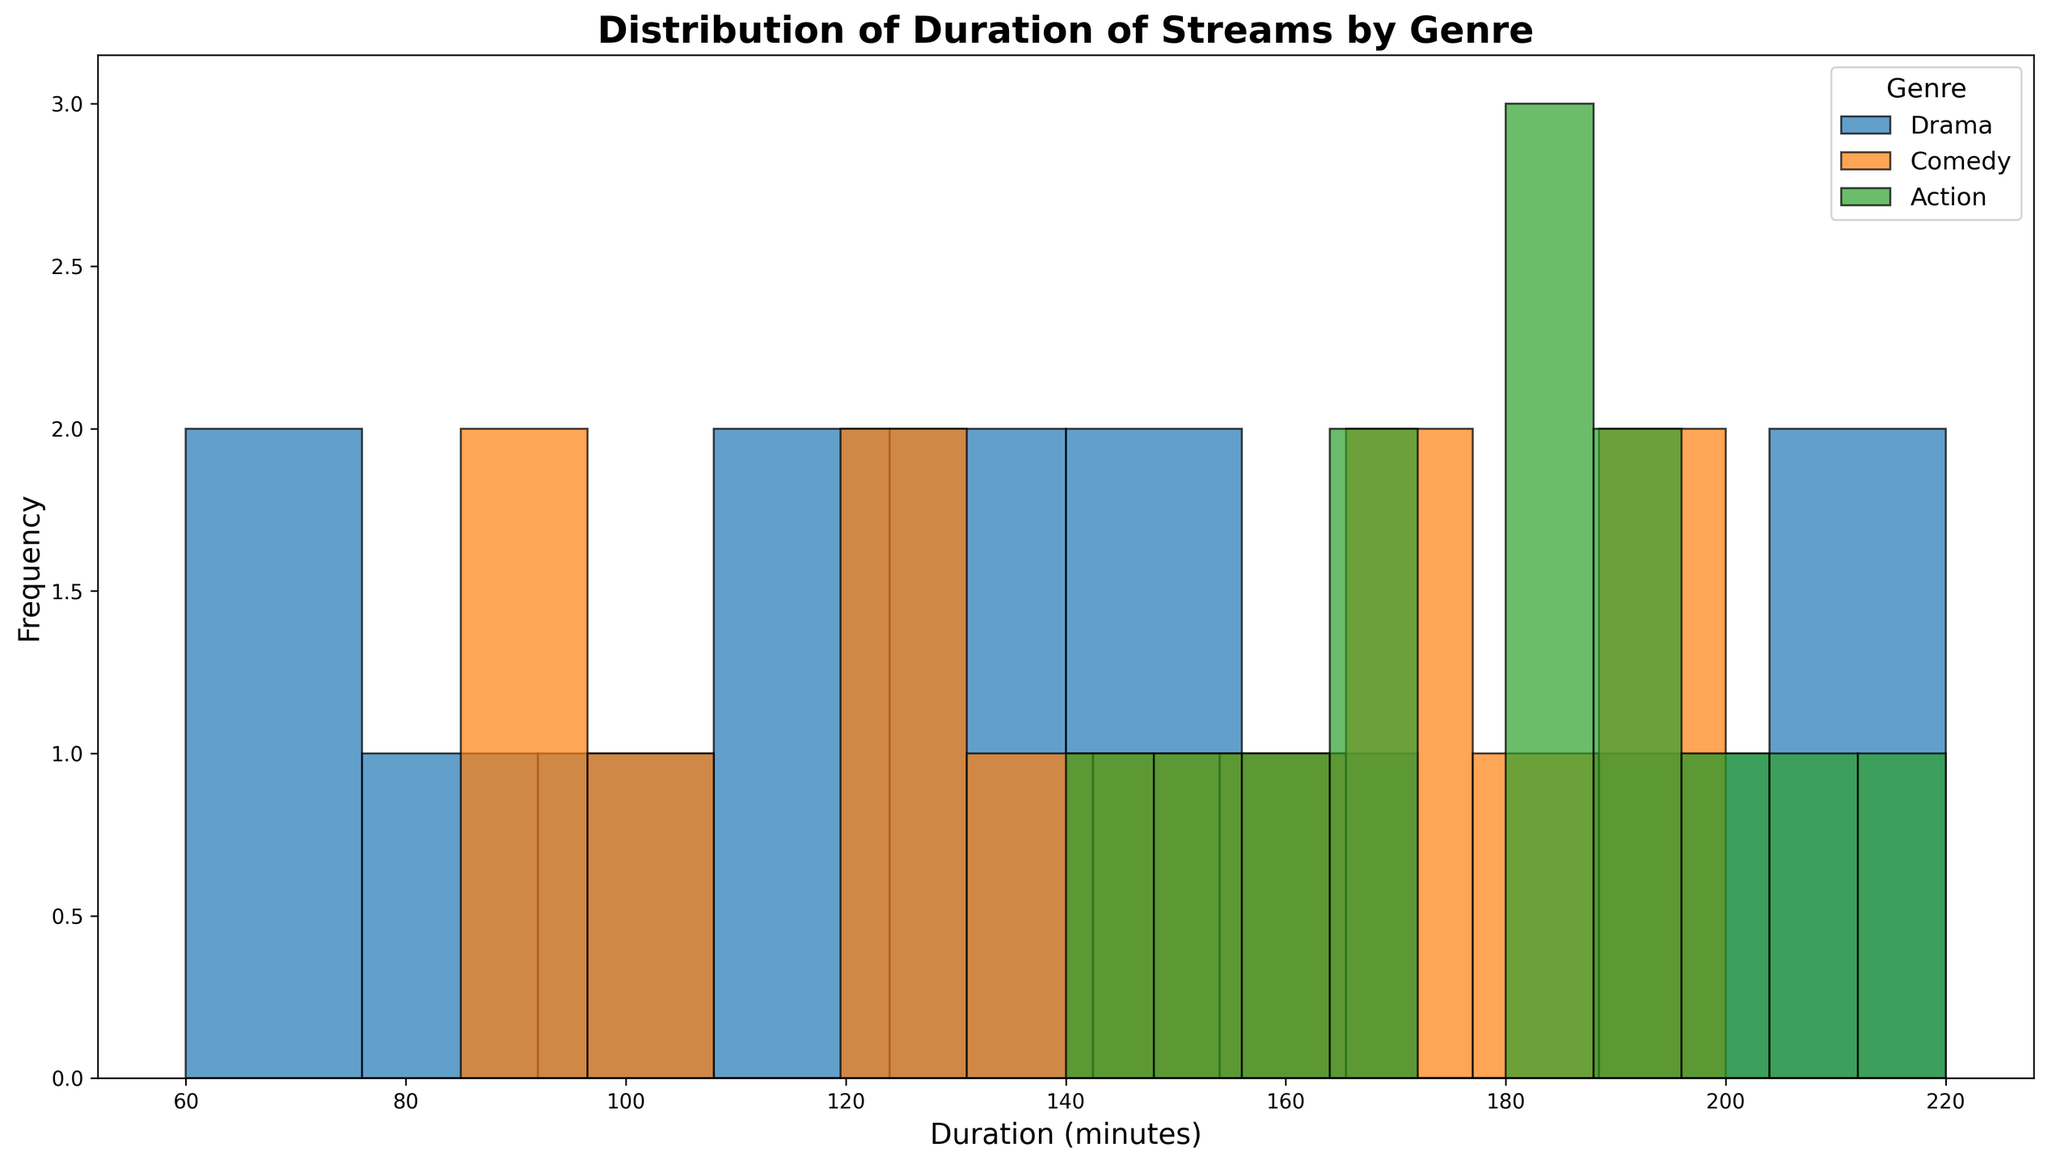What is the most frequent duration range for the Drama genre? To find the most frequent duration range, look at the tallest bar in the histogram specifically for the Drama genre. This bar represents the most common duration range.
Answer: 100-120 minutes Which genre has the widest spread of duration times? To determine which genre has the widest spread, look for the genre whose bars span the largest range of values on the x-axis (duration times).
Answer: Action What is the combined frequency of streams between 100 and 200 minutes for the Comedy genre? To find the combined frequency, sum the heights of all bars in the Comedy genre that fall within the 100-200 minutes duration range.
Answer: The sum of the heights of the relevant bars How do the peak frequencies of Drama and Action durations compare? Compare the tallest bar in the Drama histogram to the tallest bar in the Action histogram to see which one is higher.
Answer: Drama has a higher peak frequency Which genre has a higher frequency of streams longer than 190 minutes, Drama or Comedy? To answer this, compare the heights of the bars for durations longer than 190 minutes for both Drama and Comedy genres.
Answer: Drama What is the range of durations for the Action genre? Identify the minimum and maximum duration values where the bars for the Action genre start and end on the x-axis.
Answer: 140-220 minutes Among Drama, Comedy, and Action, which genre has the lowest minimum duration? Look at the first bar on the left for each genre to determine which one starts at the lowest duration value.
Answer: Drama In which duration range does Comedy have its second highest frequency of streams? Locate the second tallest bar for the Comedy genre and note the duration range it represents.
Answer: 160-180 minutes How many genres have their highest frequency in the 180-200 minutes range? Check the heights of the bars in the 180-200 minutes range for all genres to see how many peak at these durations.
Answer: 2 genres What is the difference in the highest frequencies between Drama and Comedy? Identify the height of the tallest bars for Drama and Comedy and subtract the shorter height from the taller one to find the difference.
Answer: The difference in their peak frequencies 